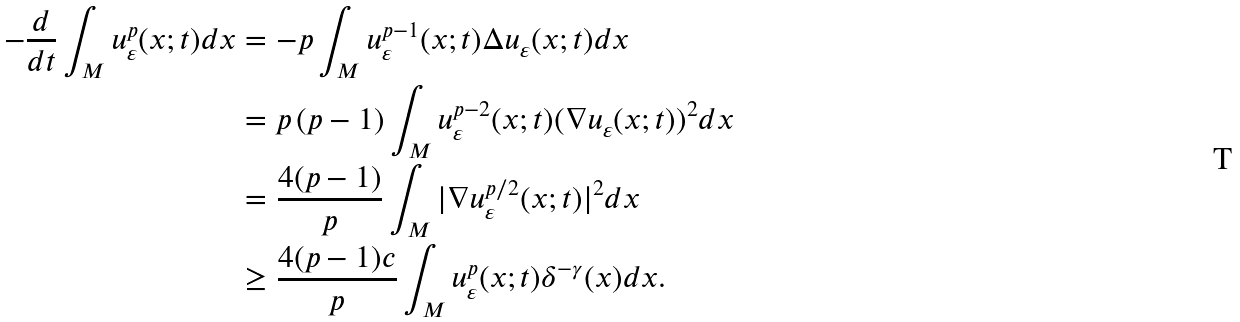<formula> <loc_0><loc_0><loc_500><loc_500>- \frac { d } { d t } \int _ { M } u _ { \varepsilon } ^ { p } ( x ; t ) d x & = - p \int _ { M } u ^ { p - 1 } _ { \varepsilon } ( x ; t ) \Delta u _ { \varepsilon } ( x ; t ) d x \\ & = p \, ( p - 1 ) \int _ { M } u _ { \varepsilon } ^ { p - 2 } ( x ; t ) ( \nabla u _ { \varepsilon } ( x ; t ) ) ^ { 2 } d x \\ & = \frac { 4 ( p - 1 ) } { p } \int _ { M } | \nabla u _ { \varepsilon } ^ { p / 2 } ( x ; t ) | ^ { 2 } d x \\ & \geq \frac { 4 ( p - 1 ) c } { p } \int _ { M } u ^ { p } _ { \varepsilon } ( x ; t ) \delta ^ { - \gamma } ( x ) d x .</formula> 